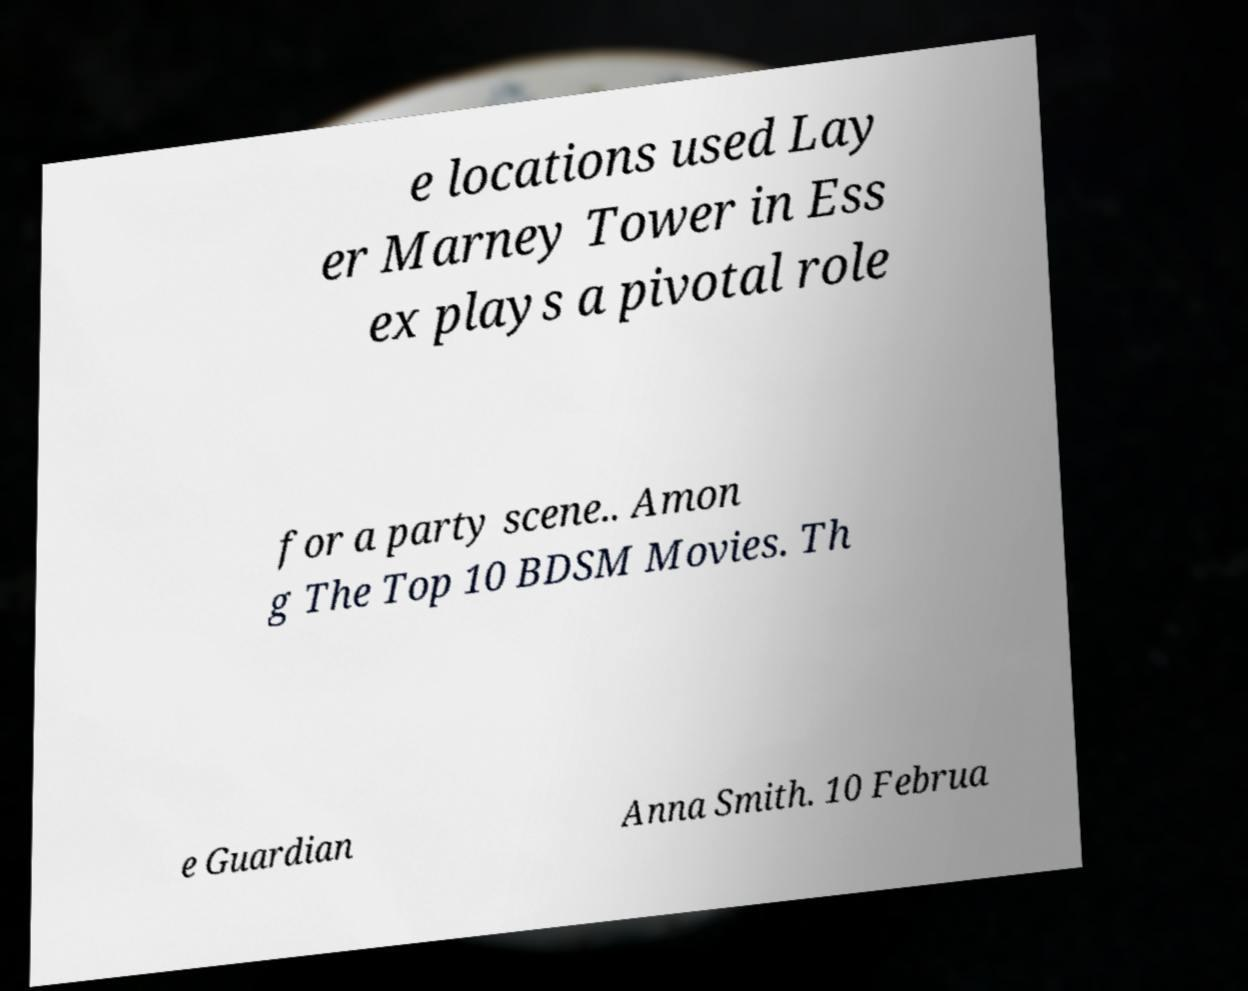For documentation purposes, I need the text within this image transcribed. Could you provide that? e locations used Lay er Marney Tower in Ess ex plays a pivotal role for a party scene.. Amon g The Top 10 BDSM Movies. Th e Guardian Anna Smith. 10 Februa 